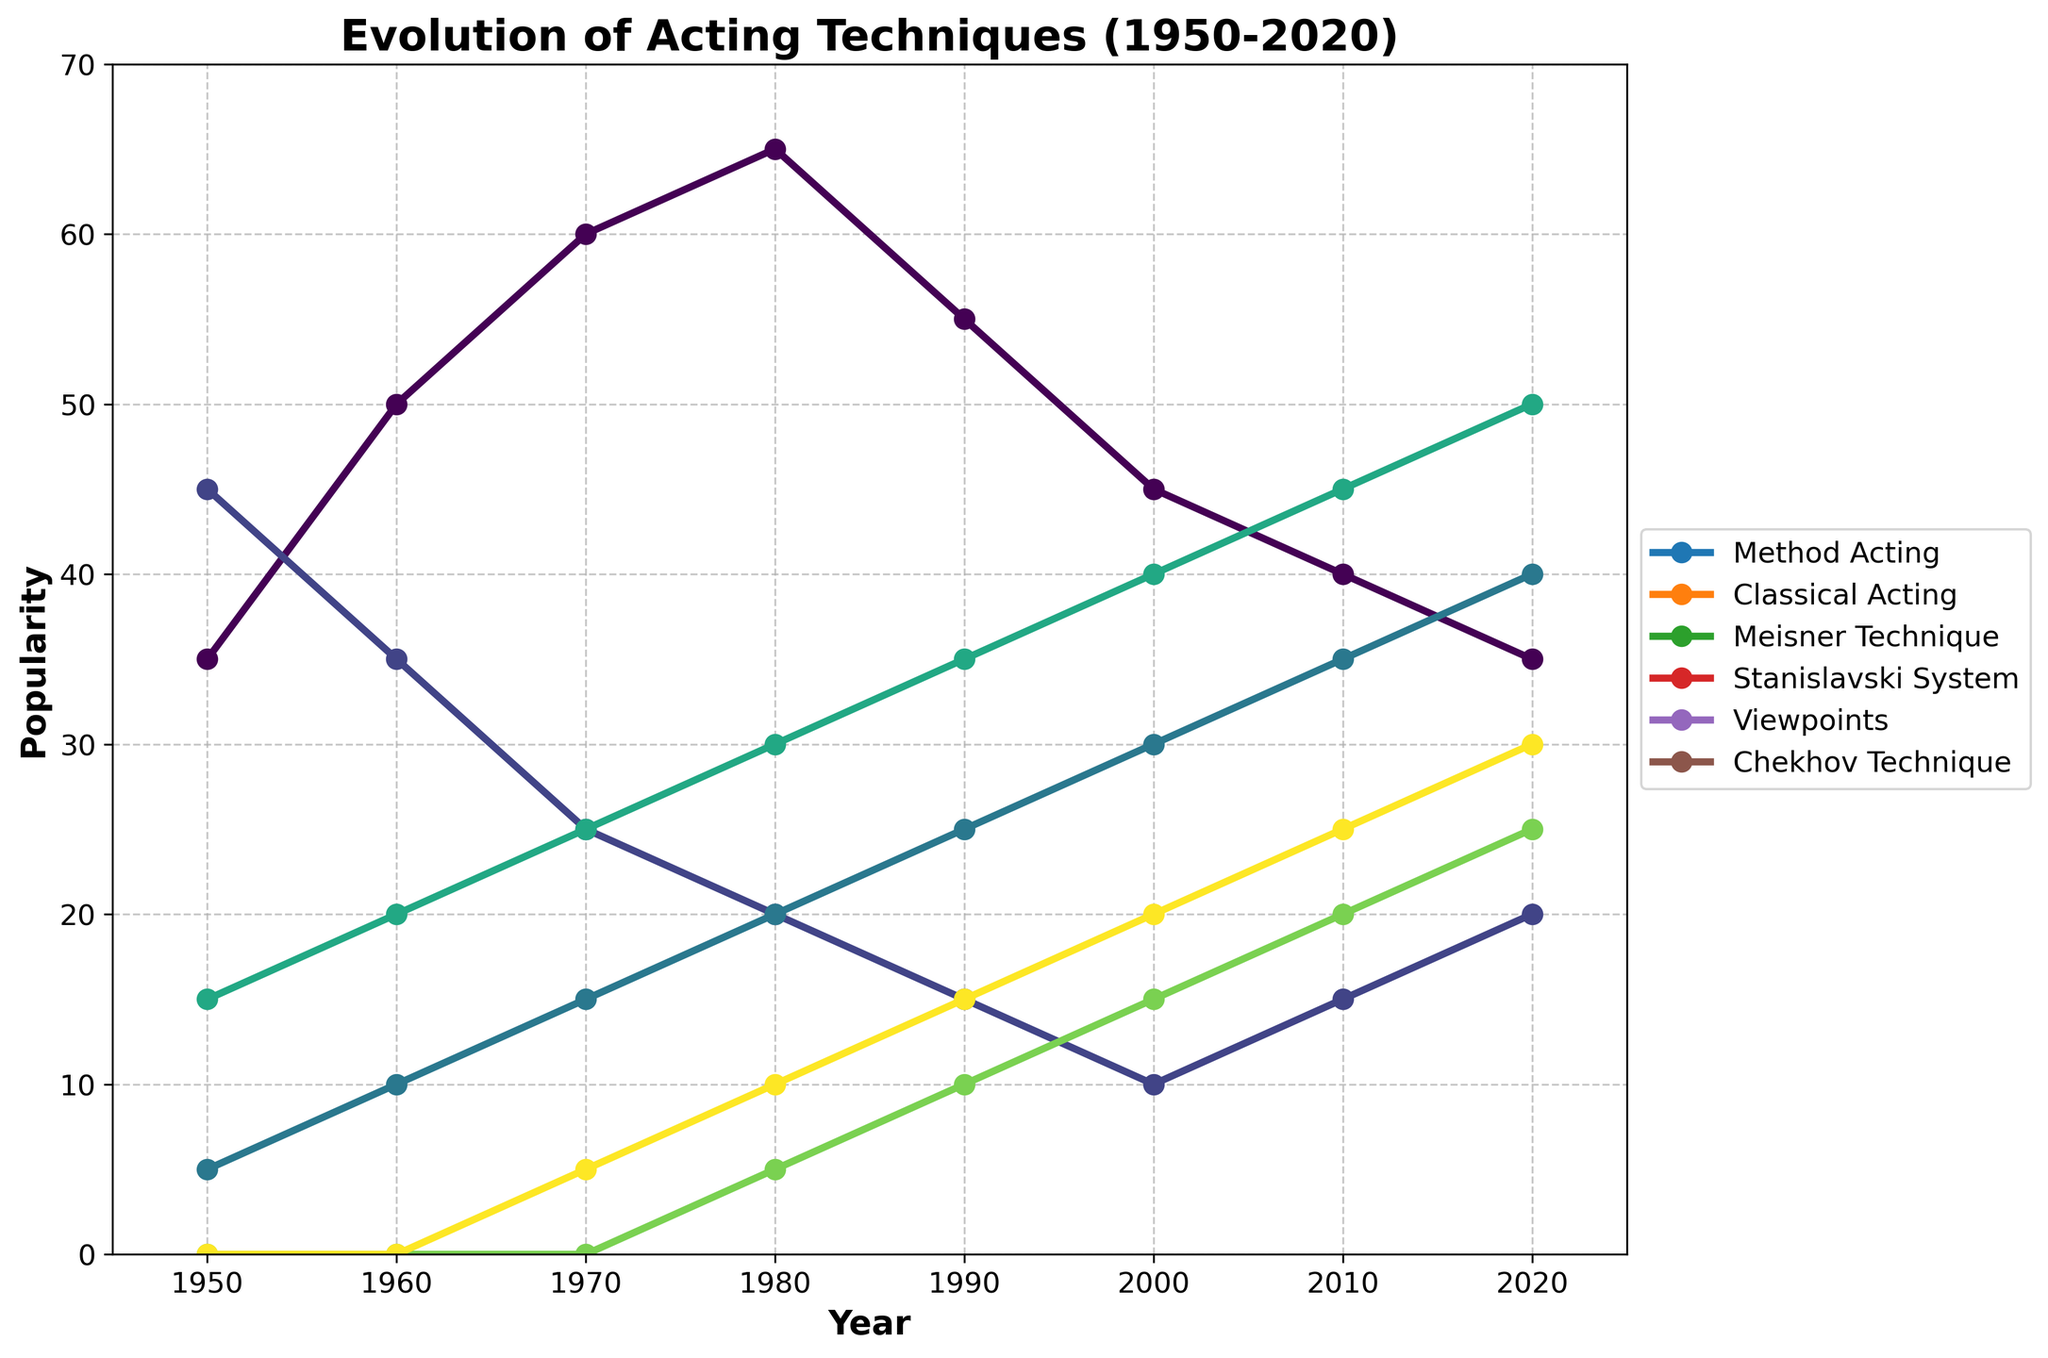What's the most popular acting technique in 1980? The line representing Method Acting is the highest in 1980, with a value of 65.
Answer: Method Acting How did the popularity of the Stanislavski System change from 1950 to 2020? The popularity of the Stanislavski System increased steadily from 15 in 1950 to 50 in 2020.
Answer: Increased steadily Which acting technique saw the greatest increase in popularity between 1950 and 2020? Method Acting increased by 0 (35 to 35), Classical Acting decreased by 25 (45 to 20), Meisner Technique increased by 35 (5 to 40), Stanislavski System increased by 35 (15 to 50), Viewpoints increased by 25 (0 to 25), Chekhov Technique increased by 30 (0 to 30).
Answer: Stanislavski System and Meisner Technique What's the combined popularity score of Classical Acting and Chekhov Technique in 2000? In 2000, the popularity score of Classical Acting is 10, and Chekhov Technique is 20. Their combined popularity is 10 + 20.
Answer: 30 Which techniques had their peak popularity in the year 2020? Evaluating the peaks of each technique's popularity over the years, Stanislavski System (50), Viewpoints (25), Chekhov Technique (30), and Meisner Technique (40) had their peak popularity in 2020.
Answer: Stanislavski System, Viewpoints, Chekhov Technique, Meisner Technique Between 1960 and 1990, which technique(s) consistently gained popularity? By comparing the values in 1960, 1970, 1980, and 1990, it is evident that Meisner Technique (10, 15, 20, 25), Stanislavski System (20, 25, 30, 35), and Chekhov Technique (0, 5, 10, 15) show continuous growth.
Answer: Meisner Technique, Stanislavski System, Chekhov Technique In what year did Viewpoints first appear, and what was its popularity in that year? Viewpoints first appears on the chart in 1980 with a popularity of 5.
Answer: 1980, 5 Which technique had the least change in popularity from 1950 to 2020? By comparing the beginning and end values: Method Acting (35 to 35, 0 difference), Classical Acting (45 to 20, 25 difference), Meisner Technique (5 to 40, 35 difference), Stanislavski System (15 to 50, 35 difference), Viewpoints (0 to 25, 25 difference), Chekhov Technique (0 to 30, 30 difference).
Answer: Method Acting What is the average popularity of the Meisner Technique over the 8 decades represented? Summing up the popularity of the Meisner Technique over the decades (5 + 10 + 15 + 20 + 25 + 30 + 35 + 40 = 180), and dividing by 8 years.
Answer: 22.5 